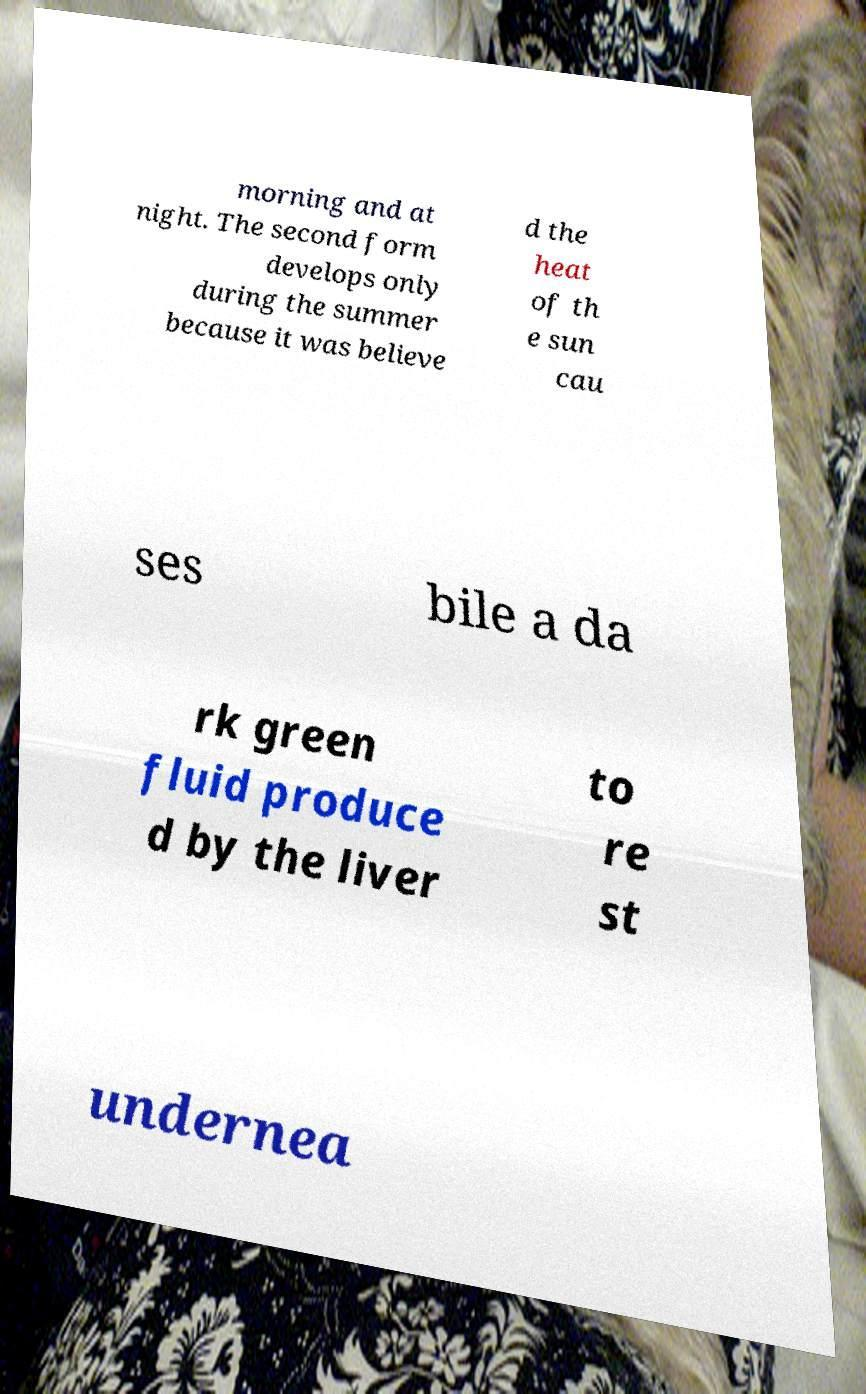Can you accurately transcribe the text from the provided image for me? morning and at night. The second form develops only during the summer because it was believe d the heat of th e sun cau ses bile a da rk green fluid produce d by the liver to re st undernea 